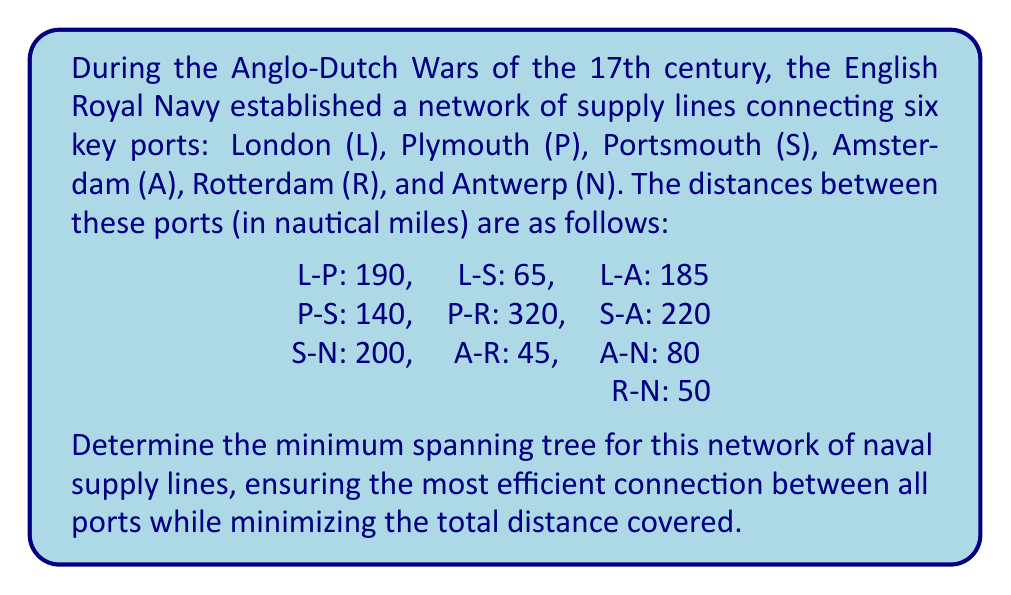Teach me how to tackle this problem. To solve this problem, we'll use Kruskal's algorithm to find the minimum spanning tree (MST) of the given network. Here are the steps:

1. Sort all edges in ascending order of weight (distance):
   A-R: 45
   R-N: 50
   L-S: 65
   A-N: 80
   L-A: 185
   L-P: 190
   S-N: 200
   S-A: 220
   P-S: 140
   P-R: 320

2. Initialize an empty set for the MST.

3. Iterate through the sorted edges:
   a) A-R (45): Add to MST
   b) R-N (50): Add to MST
   c) L-S (65): Add to MST
   d) A-N (80): Skip (would create a cycle)
   e) L-A (185): Add to MST
   f) L-P (190): Add to MST

4. Stop as we have included 5 edges for 6 vertices.

The resulting MST includes the following edges:
1. A-R (45 nautical miles)
2. R-N (50 nautical miles)
3. L-S (65 nautical miles)
4. L-A (185 nautical miles)
5. L-P (190 nautical miles)

The total distance covered by the minimum spanning tree is:
$$45 + 50 + 65 + 185 + 190 = 535$$ nautical miles

This MST ensures that all six ports are connected with the minimum total distance of supply lines.
Answer: The minimum spanning tree for the network of naval supply lines consists of the following connections:
1. Amsterdam - Rotterdam
2. Rotterdam - Antwerp
3. London - Portsmouth
4. London - Amsterdam
5. London - Plymouth

Total distance: 535 nautical miles 